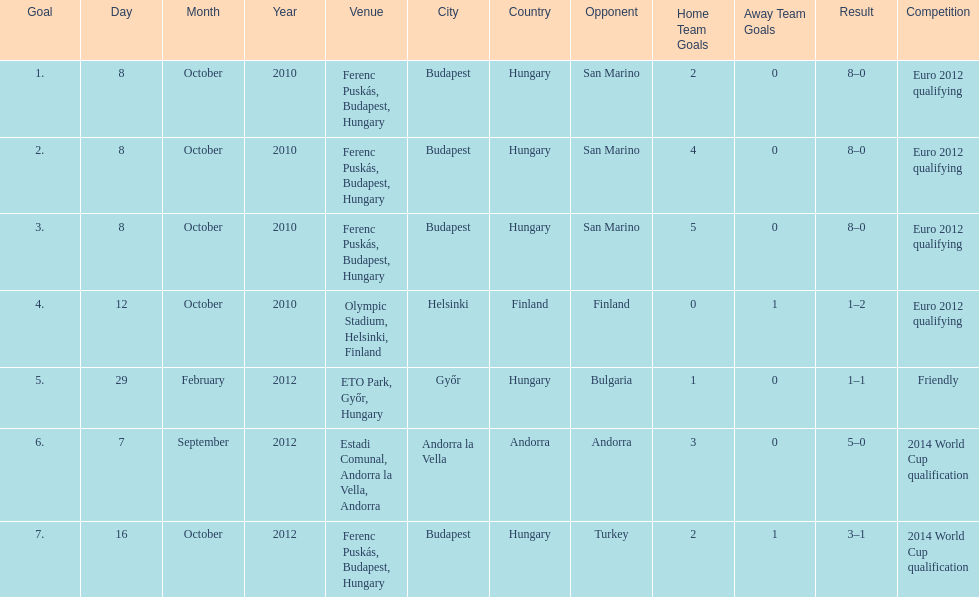How many non-qualifying games did he score in? 1. 